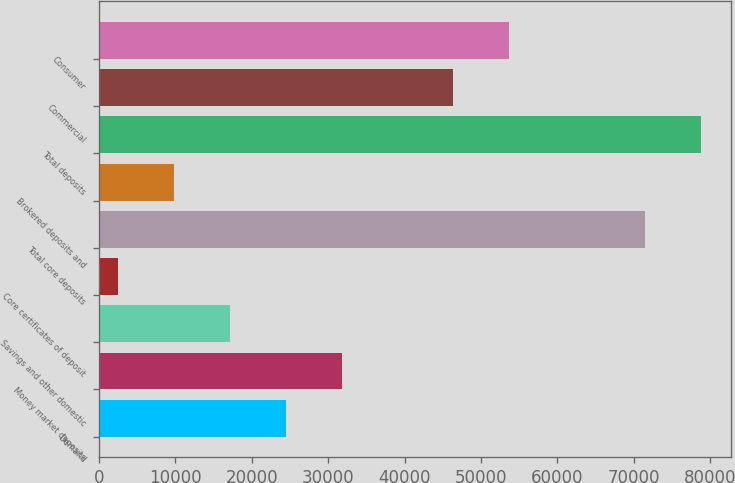<chart> <loc_0><loc_0><loc_500><loc_500><bar_chart><fcel>Demand<fcel>Money market deposits<fcel>Savings and other domestic<fcel>Core certificates of deposit<fcel>Total core deposits<fcel>Brokered deposits and<fcel>Total deposits<fcel>Commercial<fcel>Consumer<nl><fcel>24456.9<fcel>31764.2<fcel>17149.6<fcel>2535<fcel>71429<fcel>9842.3<fcel>78736.3<fcel>46378.8<fcel>53686.1<nl></chart> 